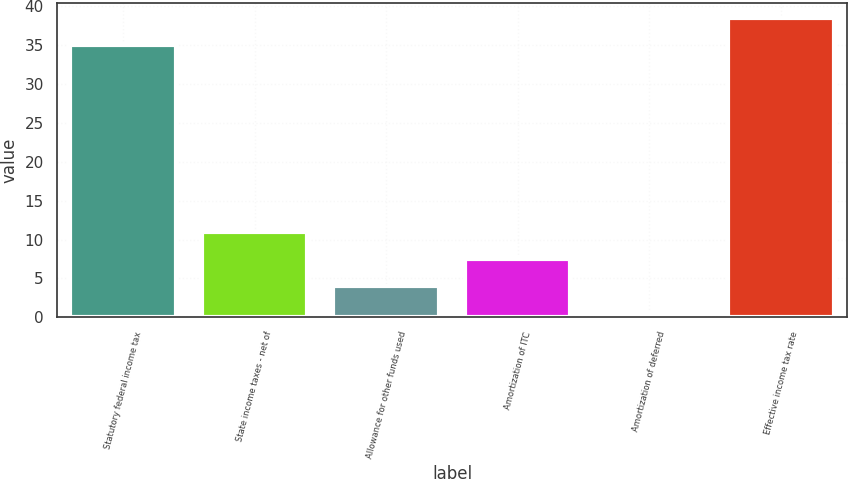<chart> <loc_0><loc_0><loc_500><loc_500><bar_chart><fcel>Statutory federal income tax<fcel>State income taxes - net of<fcel>Allowance for other funds used<fcel>Amortization of ITC<fcel>Amortization of deferred<fcel>Effective income tax rate<nl><fcel>35<fcel>11.01<fcel>4.07<fcel>7.54<fcel>0.6<fcel>38.47<nl></chart> 